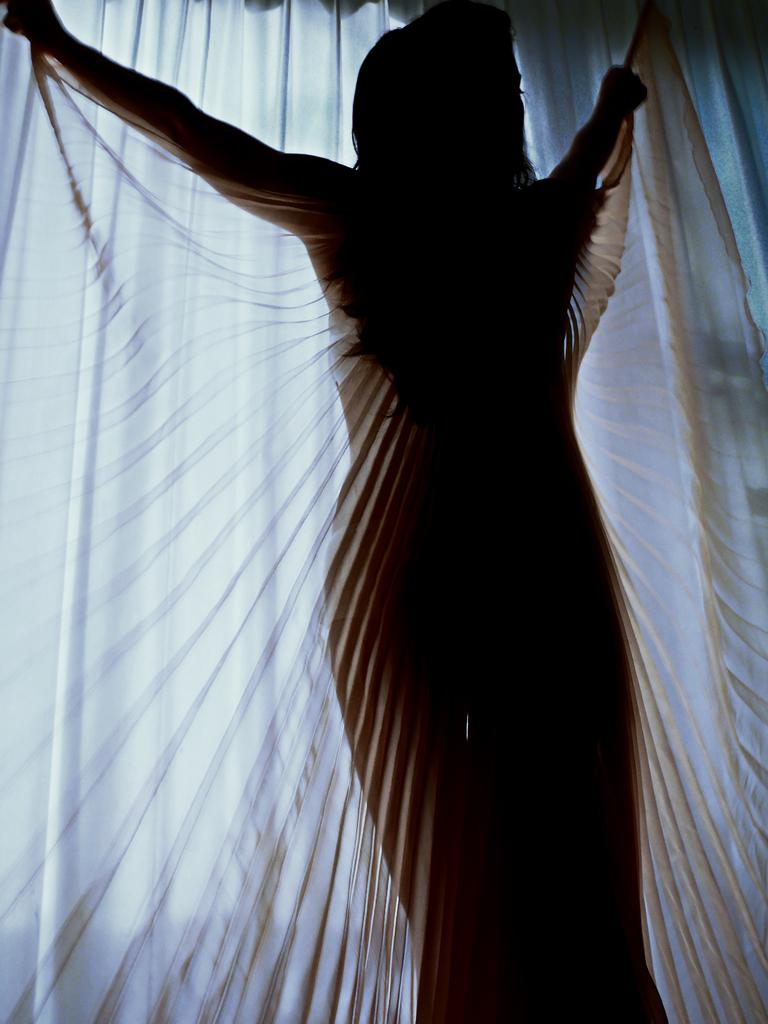What is the main subject of the image? There is a person in the image. What is the person holding in their hands? The person is holding a cloth in their hands. What can be seen in the background of the image? There is a curtain and an unspecified object in the background of the image. What type of smoke can be seen coming from the person's mouth in the image? There is no smoke visible in the image; the person is holding a cloth in their hands. 